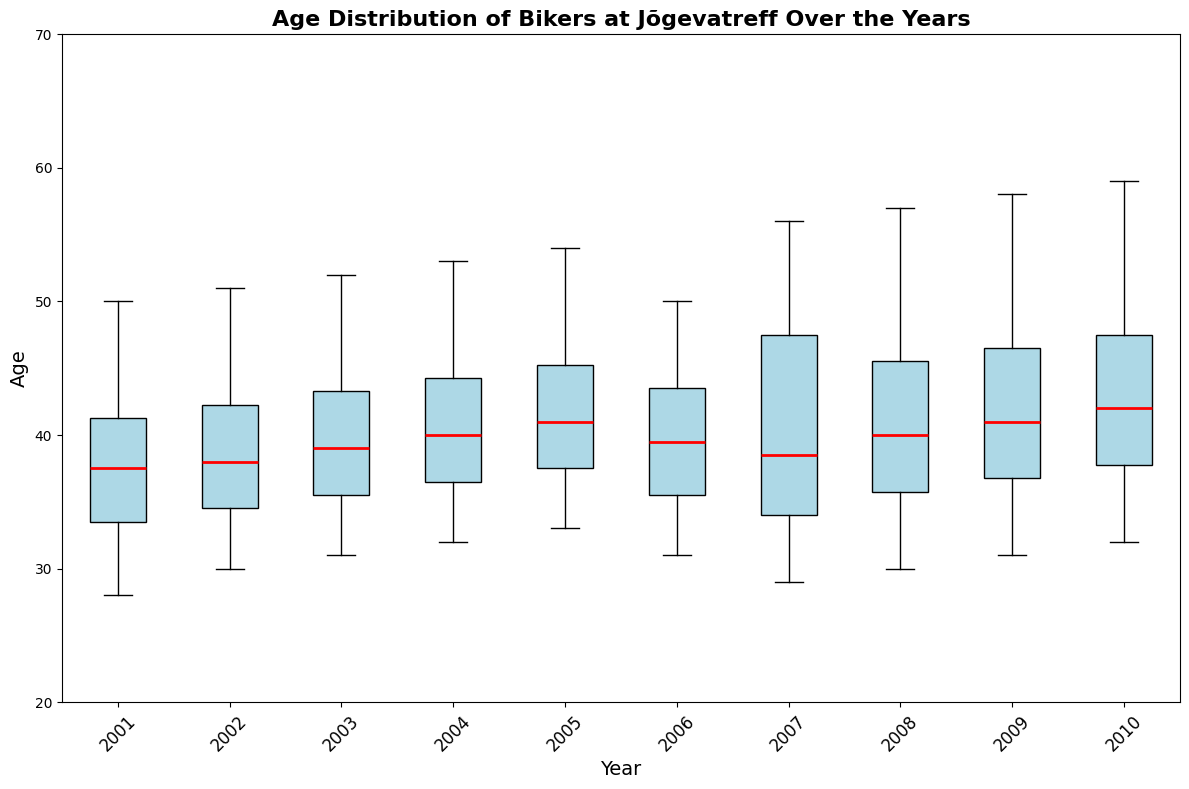What is the median age of bikers in 2001? To determine the median age of bikers in 2001, locate the box for the year 2001, then find the value of the line inside the box, which represents the median.
Answer: 37 Which year has the widest range of age distribution? To find the year with the widest range, look for the year where the distance between the bottom of the lower whisker and the top of the upper whisker (representing the minimum and maximum ages) is the largest.
Answer: 2007 Did the median age of bikers increase or decrease from 2001 to 2005? First, find the median age for 2001 and 2005 by locating the line inside the box for each year. Compare these two values to determine if the median increased or decreased.
Answer: Increase In which year was the youngest biker and how old were they? Locate the lowest point on the plot (whiskers) across all years to identify the youngest biker and the corresponding year. Note the value associated with this lowest point.
Answer: 2007, 29 What is the interquartile range (IQR) for the age distribution in 2005? The IQR is found by subtracting the value at the bottom of the box (25th percentile) from the value at the top of the box (75th percentile) for the year 2005.
Answer: 8 Which year shows the most consistent age distribution (least spread)? Find the year where the box (representing the interquartile range) is the smallest. This indicates the least variability in age.
Answer: 2001 Compare the median age of bikers in 2002 and 2006. Which year had an older median age? Identify the median age for both 2002 and 2006 by locating the line inside the boxes for these years and comparing the two values.
Answer: 2006 Did the variability in biker ages increase or decrease from 2004 to 2010? Compare the length of the boxes and whiskers from 2004 and 2010 to determine if the variability (spread of ages) increased or decreased.
Answer: Increase What is the maximum age of bikers in 2008? Find the top of the upper whisker for the year 2008, which indicates the maximum age of bikers for that year.
Answer: 57 Which years have a median age above 40? Locate the boxes for all years and identify which years have the red median line above the 40 mark on the y-axis.
Answer: 2006, 2007, 2008, 2009, 2010 